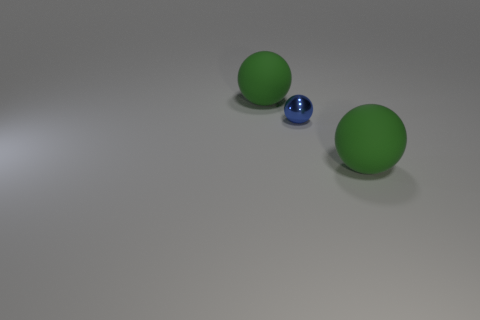Add 3 small metal balls. How many objects exist? 6 Add 3 shiny balls. How many shiny balls exist? 4 Subtract 0 brown spheres. How many objects are left? 3 Subtract all green rubber objects. Subtract all tiny blue metal spheres. How many objects are left? 0 Add 1 green rubber things. How many green rubber things are left? 3 